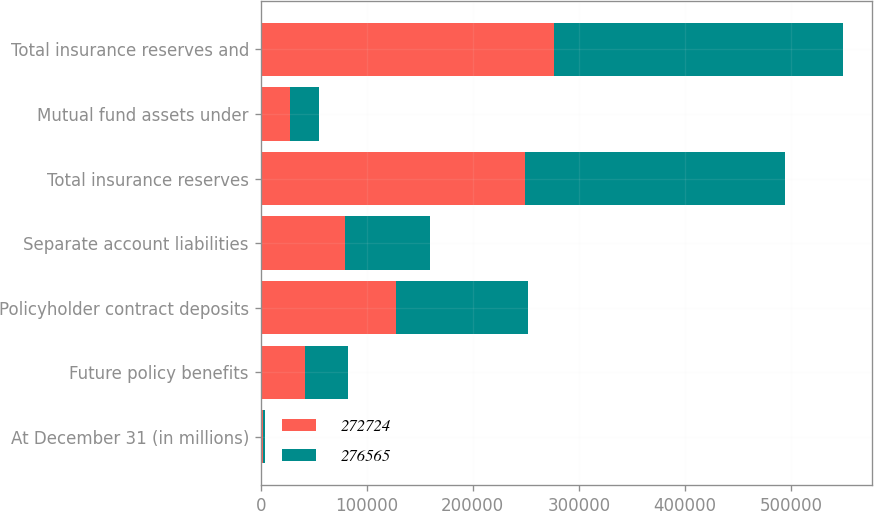Convert chart. <chart><loc_0><loc_0><loc_500><loc_500><stacked_bar_chart><ecel><fcel>At December 31 (in millions)<fcel>Future policy benefits<fcel>Policyholder contract deposits<fcel>Separate account liabilities<fcel>Total insurance reserves<fcel>Mutual fund assets under<fcel>Total insurance reserves and<nl><fcel>272724<fcel>2015<fcel>41562<fcel>127704<fcel>79564<fcel>248830<fcel>27735<fcel>276565<nl><fcel>276565<fcel>2014<fcel>40931<fcel>124716<fcel>80025<fcel>245672<fcel>27052<fcel>272724<nl></chart> 